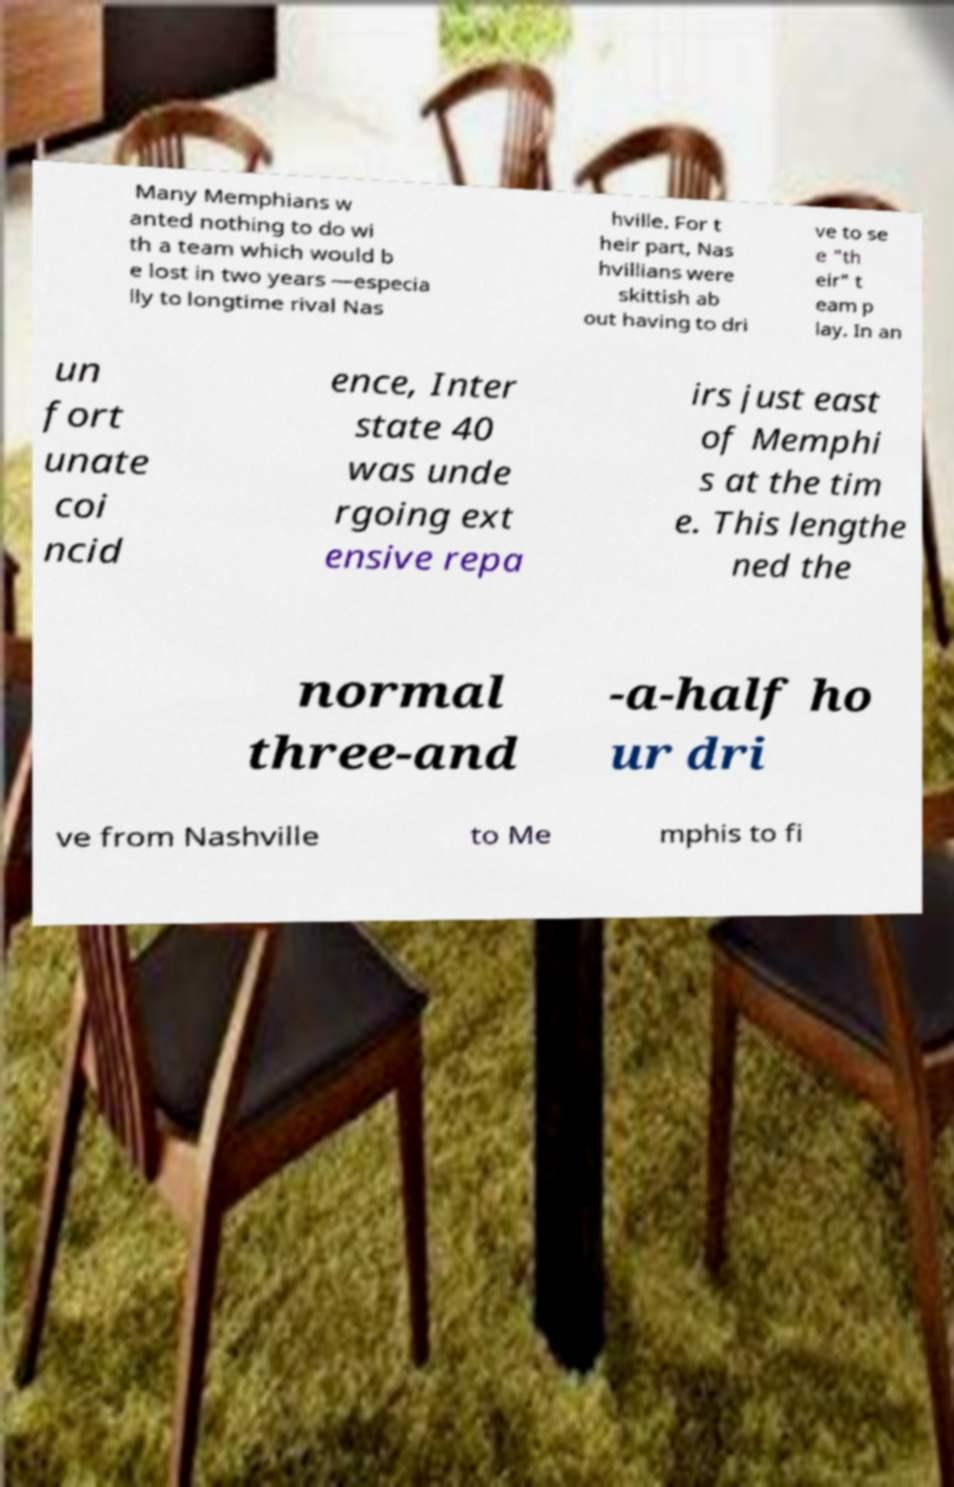Could you assist in decoding the text presented in this image and type it out clearly? Many Memphians w anted nothing to do wi th a team which would b e lost in two years —especia lly to longtime rival Nas hville. For t heir part, Nas hvillians were skittish ab out having to dri ve to se e "th eir" t eam p lay. In an un fort unate coi ncid ence, Inter state 40 was unde rgoing ext ensive repa irs just east of Memphi s at the tim e. This lengthe ned the normal three-and -a-half ho ur dri ve from Nashville to Me mphis to fi 